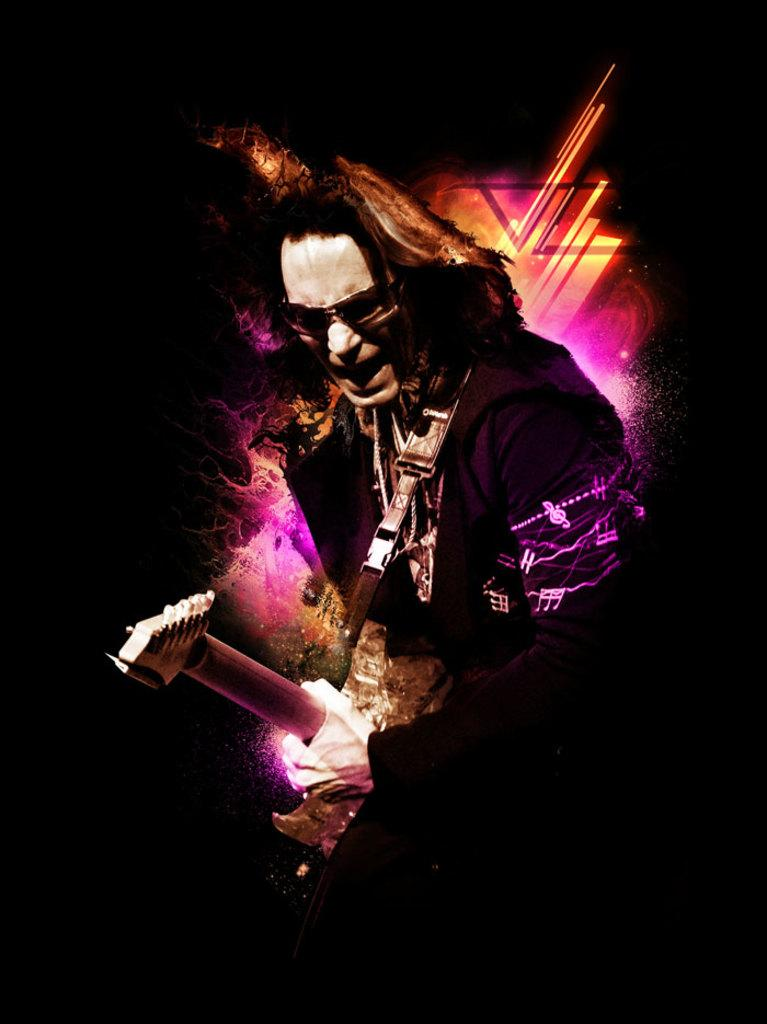What is the main subject of the image? There is a person in the image. What is the person holding in the image? The person is holding a guitar. What color is the background of the image? The background of the image is black in color. What type of badge is the person wearing on their legs in the image? There is no badge or mention of legs in the image; the person is holding a guitar and standing in front of a black background. 